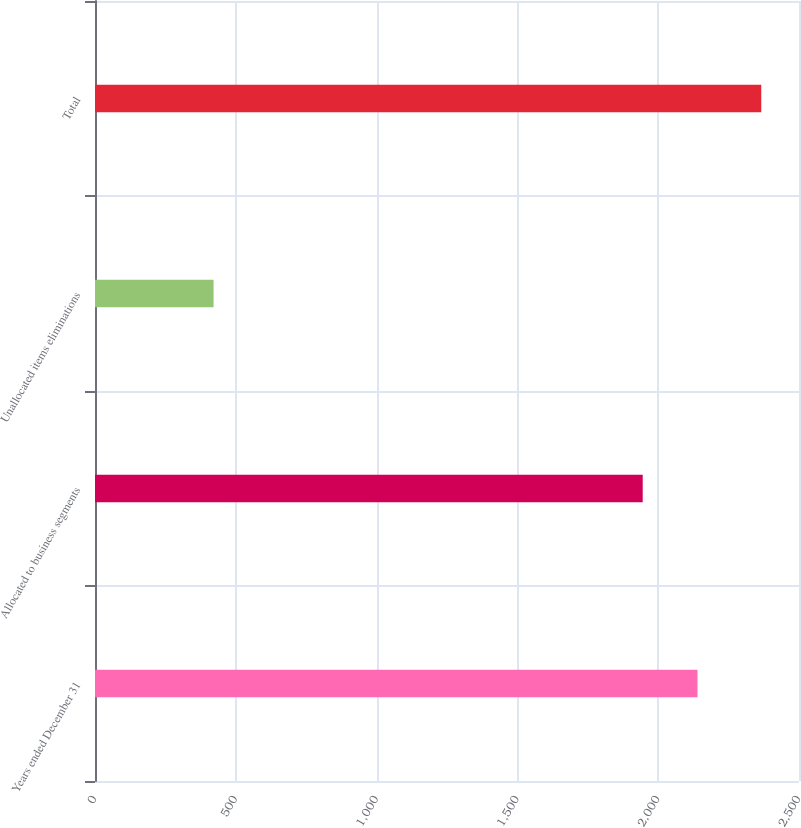Convert chart. <chart><loc_0><loc_0><loc_500><loc_500><bar_chart><fcel>Years ended December 31<fcel>Allocated to business segments<fcel>Unallocated items eliminations<fcel>Total<nl><fcel>2139.5<fcel>1945<fcel>421<fcel>2366<nl></chart> 